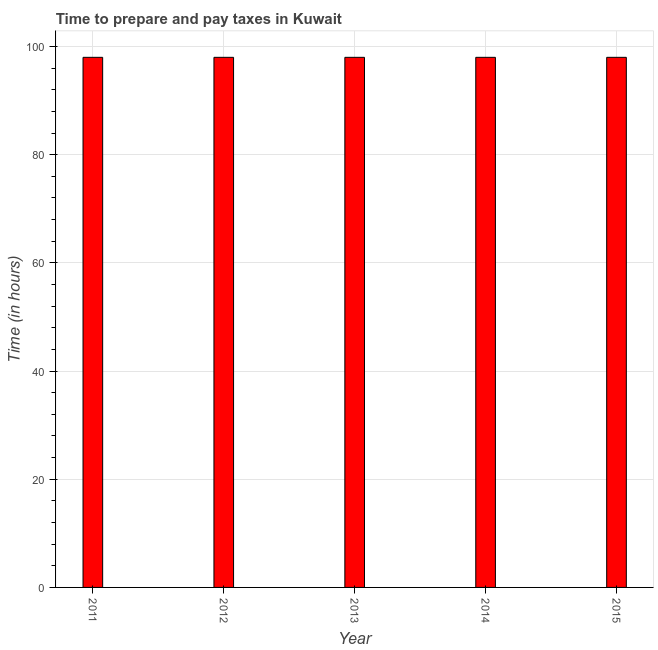Does the graph contain any zero values?
Offer a very short reply. No. Does the graph contain grids?
Provide a short and direct response. Yes. What is the title of the graph?
Make the answer very short. Time to prepare and pay taxes in Kuwait. What is the label or title of the X-axis?
Offer a very short reply. Year. What is the label or title of the Y-axis?
Provide a succinct answer. Time (in hours). Across all years, what is the maximum time to prepare and pay taxes?
Offer a very short reply. 98. Across all years, what is the minimum time to prepare and pay taxes?
Offer a terse response. 98. In which year was the time to prepare and pay taxes minimum?
Ensure brevity in your answer.  2011. What is the sum of the time to prepare and pay taxes?
Offer a terse response. 490. In how many years, is the time to prepare and pay taxes greater than 8 hours?
Make the answer very short. 5. What is the difference between the highest and the second highest time to prepare and pay taxes?
Your answer should be very brief. 0. Is the sum of the time to prepare and pay taxes in 2013 and 2014 greater than the maximum time to prepare and pay taxes across all years?
Ensure brevity in your answer.  Yes. What is the difference between the highest and the lowest time to prepare and pay taxes?
Ensure brevity in your answer.  0. How many bars are there?
Provide a short and direct response. 5. How many years are there in the graph?
Keep it short and to the point. 5. What is the difference between two consecutive major ticks on the Y-axis?
Ensure brevity in your answer.  20. What is the Time (in hours) of 2011?
Keep it short and to the point. 98. What is the Time (in hours) in 2012?
Keep it short and to the point. 98. What is the Time (in hours) in 2013?
Offer a terse response. 98. What is the Time (in hours) of 2014?
Ensure brevity in your answer.  98. What is the Time (in hours) in 2015?
Offer a terse response. 98. What is the difference between the Time (in hours) in 2011 and 2012?
Give a very brief answer. 0. What is the difference between the Time (in hours) in 2011 and 2014?
Provide a succinct answer. 0. What is the difference between the Time (in hours) in 2012 and 2014?
Provide a succinct answer. 0. What is the ratio of the Time (in hours) in 2011 to that in 2012?
Make the answer very short. 1. What is the ratio of the Time (in hours) in 2011 to that in 2013?
Offer a terse response. 1. What is the ratio of the Time (in hours) in 2011 to that in 2014?
Offer a very short reply. 1. What is the ratio of the Time (in hours) in 2011 to that in 2015?
Your response must be concise. 1. What is the ratio of the Time (in hours) in 2012 to that in 2015?
Provide a short and direct response. 1. What is the ratio of the Time (in hours) in 2013 to that in 2014?
Offer a very short reply. 1. What is the ratio of the Time (in hours) in 2013 to that in 2015?
Your answer should be very brief. 1. What is the ratio of the Time (in hours) in 2014 to that in 2015?
Ensure brevity in your answer.  1. 